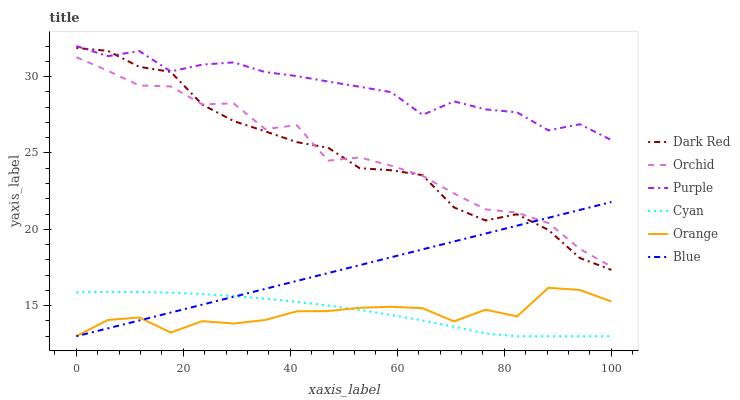Does Dark Red have the minimum area under the curve?
Answer yes or no. No. Does Dark Red have the maximum area under the curve?
Answer yes or no. No. Is Purple the smoothest?
Answer yes or no. No. Is Purple the roughest?
Answer yes or no. No. Does Dark Red have the lowest value?
Answer yes or no. No. Does Dark Red have the highest value?
Answer yes or no. No. Is Blue less than Purple?
Answer yes or no. Yes. Is Dark Red greater than Orange?
Answer yes or no. Yes. Does Blue intersect Purple?
Answer yes or no. No. 